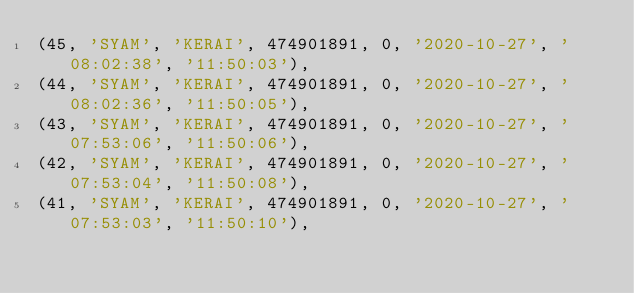<code> <loc_0><loc_0><loc_500><loc_500><_SQL_>(45, 'SYAM', 'KERAI', 474901891, 0, '2020-10-27', '08:02:38', '11:50:03'),
(44, 'SYAM', 'KERAI', 474901891, 0, '2020-10-27', '08:02:36', '11:50:05'),
(43, 'SYAM', 'KERAI', 474901891, 0, '2020-10-27', '07:53:06', '11:50:06'),
(42, 'SYAM', 'KERAI', 474901891, 0, '2020-10-27', '07:53:04', '11:50:08'),
(41, 'SYAM', 'KERAI', 474901891, 0, '2020-10-27', '07:53:03', '11:50:10'),</code> 